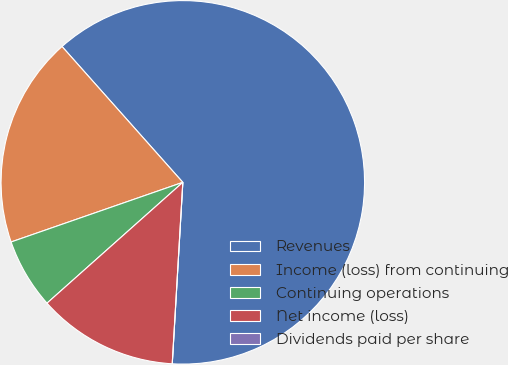Convert chart to OTSL. <chart><loc_0><loc_0><loc_500><loc_500><pie_chart><fcel>Revenues<fcel>Income (loss) from continuing<fcel>Continuing operations<fcel>Net income (loss)<fcel>Dividends paid per share<nl><fcel>62.49%<fcel>18.75%<fcel>6.25%<fcel>12.5%<fcel>0.0%<nl></chart> 